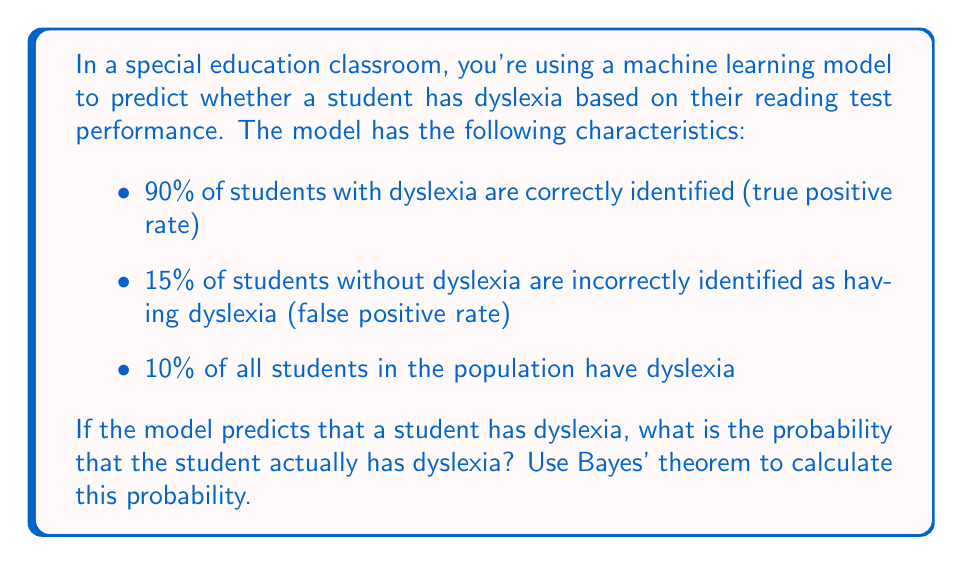Provide a solution to this math problem. To solve this problem, we'll use Bayes' theorem in the context of machine learning. Let's define our events:

A: The student actually has dyslexia
B: The model predicts the student has dyslexia

We want to find P(A|B), which is the probability that a student has dyslexia given that the model predicted they have dyslexia.

Bayes' theorem states:

$$ P(A|B) = \frac{P(B|A) \cdot P(A)}{P(B)} $$

Let's break down the components:

1. P(B|A) = 0.90 (true positive rate)
2. P(A) = 0.10 (prevalence of dyslexia in the population)
3. P(B) = P(B|A) · P(A) + P(B|not A) · P(not A)

To calculate P(B):
- P(B|not A) = 0.15 (false positive rate)
- P(not A) = 1 - P(A) = 0.90

$$ P(B) = 0.90 \cdot 0.10 + 0.15 \cdot 0.90 = 0.09 + 0.135 = 0.225 $$

Now we can apply Bayes' theorem:

$$ P(A|B) = \frac{0.90 \cdot 0.10}{0.225} = \frac{0.09}{0.225} = 0.4 $$

Therefore, the probability that a student actually has dyslexia, given that the model predicted they have dyslexia, is 0.4 or 40%.
Answer: The probability that a student actually has dyslexia, given that the machine learning model predicted they have dyslexia, is 0.4 or 40%. 